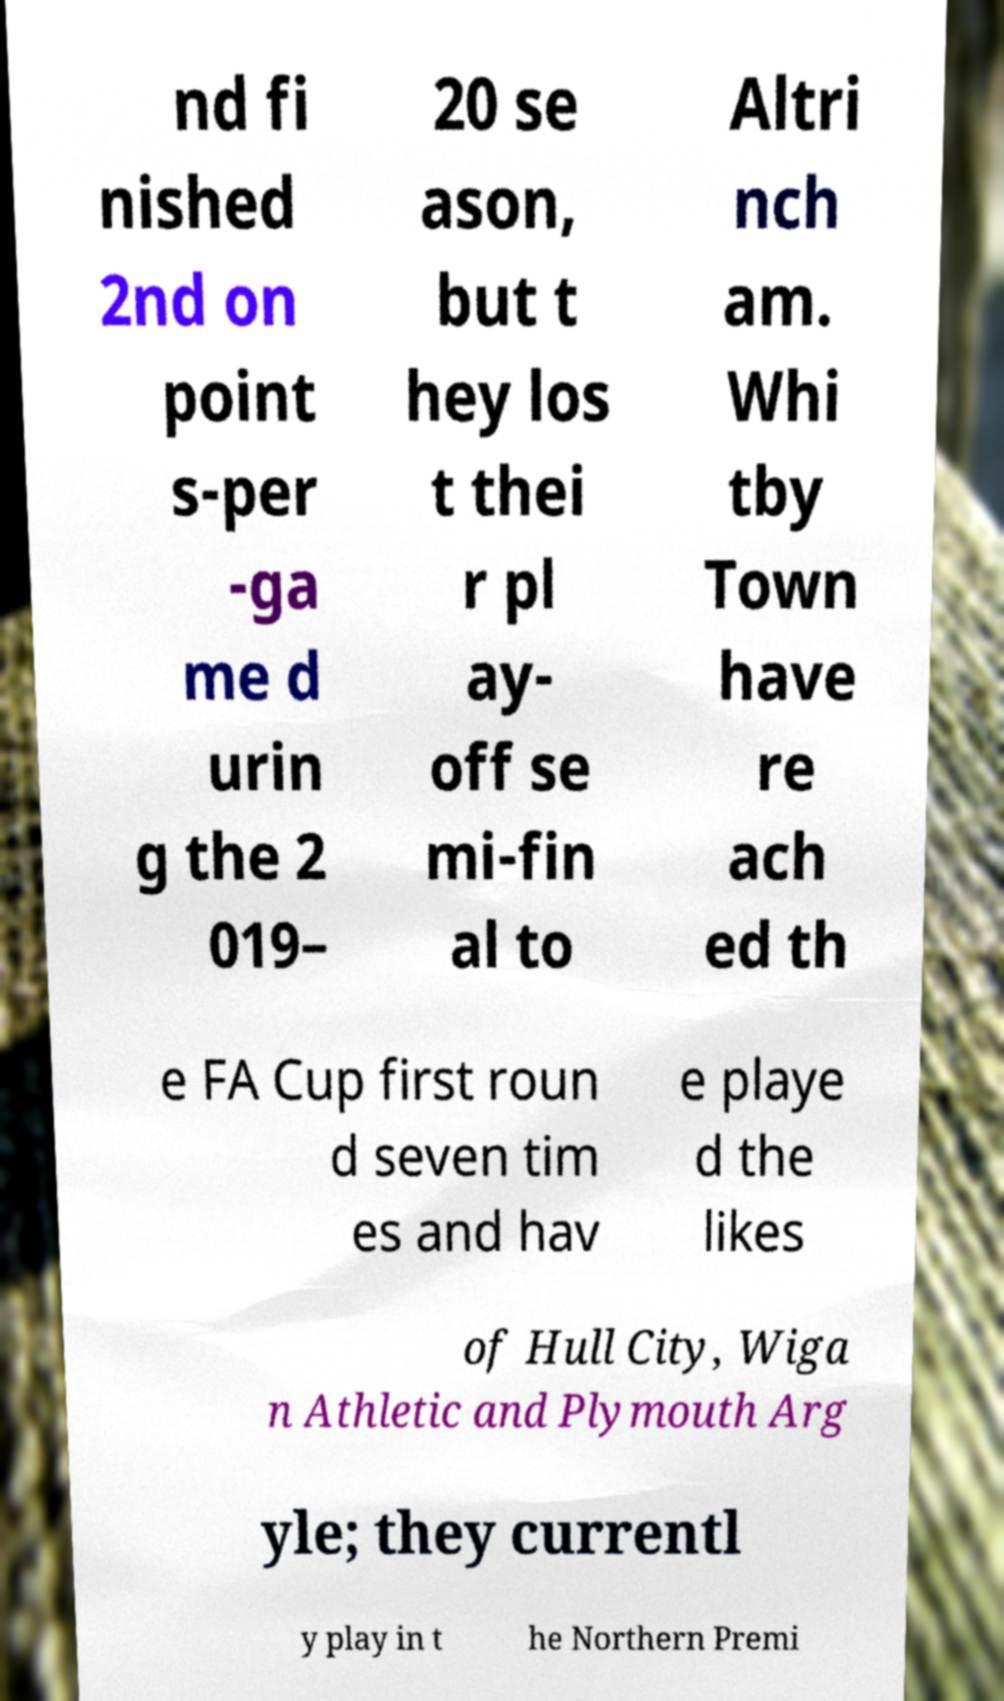Can you accurately transcribe the text from the provided image for me? nd fi nished 2nd on point s-per -ga me d urin g the 2 019– 20 se ason, but t hey los t thei r pl ay- off se mi-fin al to Altri nch am. Whi tby Town have re ach ed th e FA Cup first roun d seven tim es and hav e playe d the likes of Hull City, Wiga n Athletic and Plymouth Arg yle; they currentl y play in t he Northern Premi 